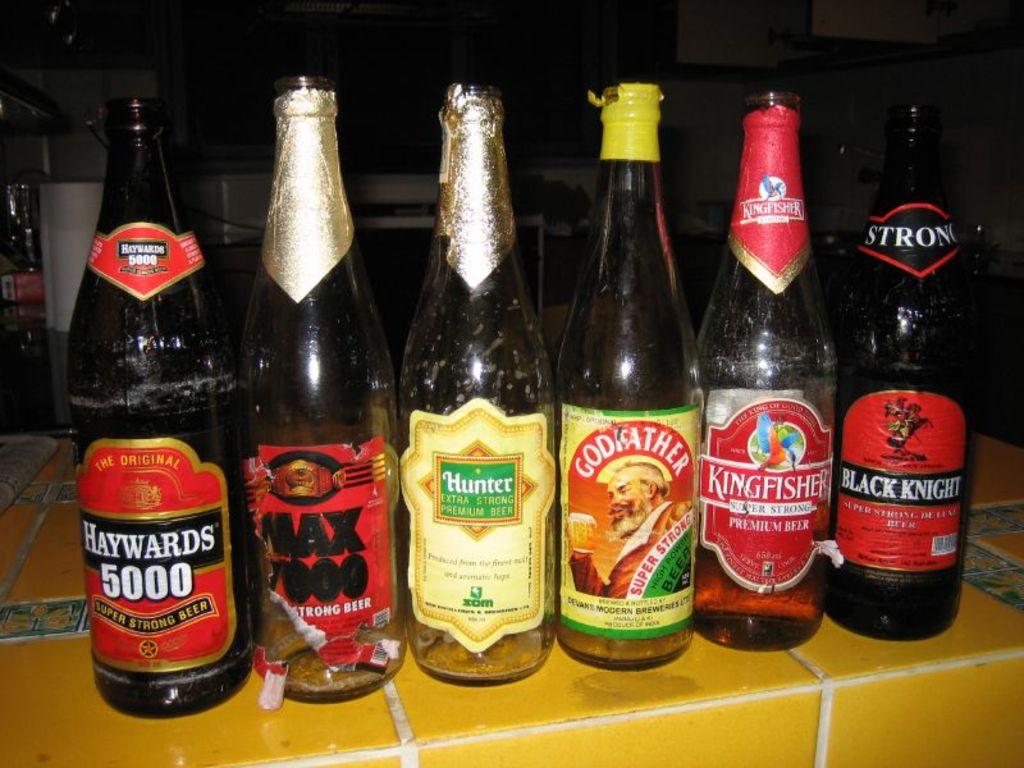What's the brand name of the beer on the far left?
Give a very brief answer. Haywards 5000. What is the brand name of the beer that says "super strong" on the label?
Offer a very short reply. Godfather. 